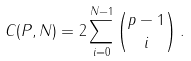Convert formula to latex. <formula><loc_0><loc_0><loc_500><loc_500>C ( P , N ) = 2 \sum _ { i = 0 } ^ { N - 1 } \binom { p - 1 } { i } \, .</formula> 